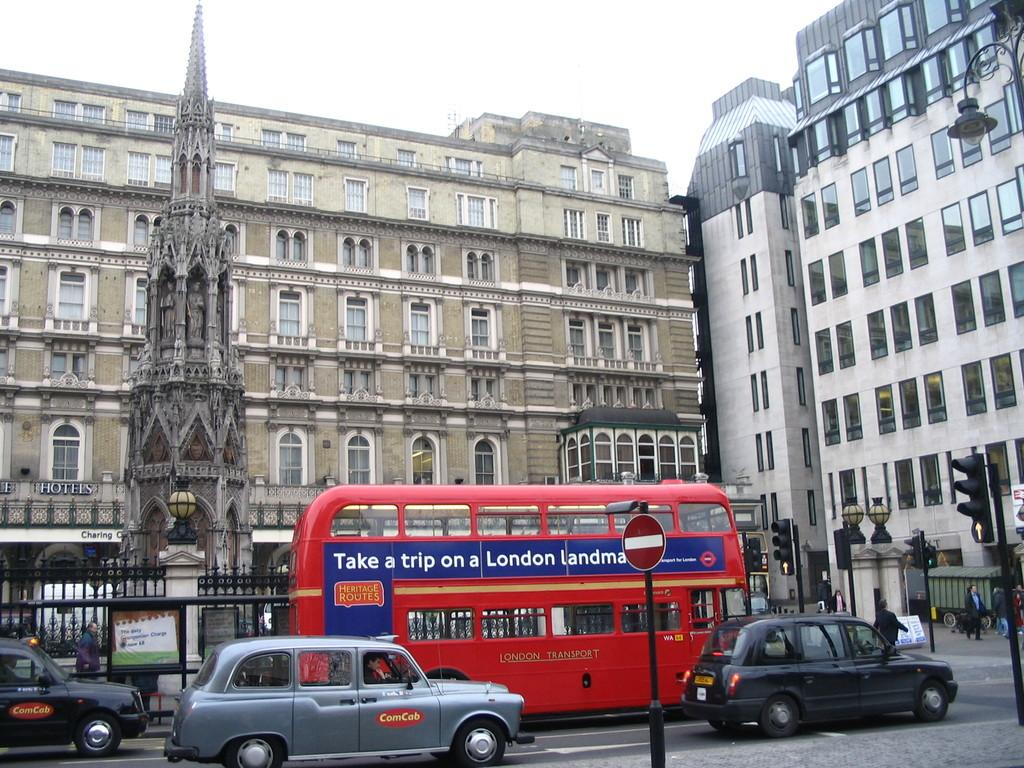<image>
Give a short and clear explanation of the subsequent image. Heritage Routes has a double decker bus to take you around town. 